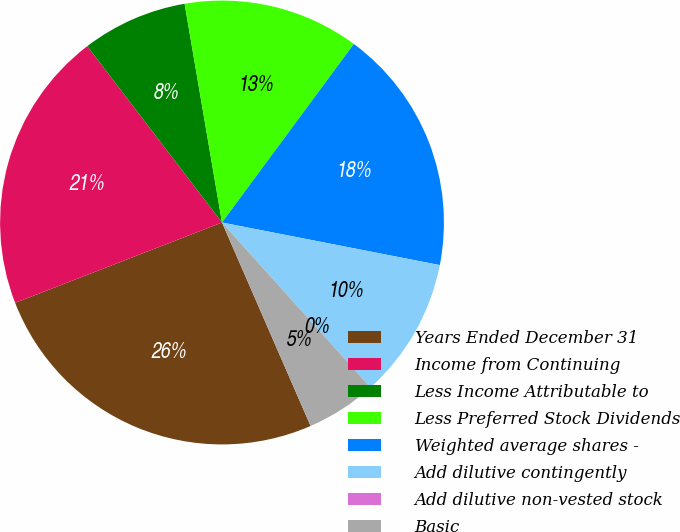<chart> <loc_0><loc_0><loc_500><loc_500><pie_chart><fcel>Years Ended December 31<fcel>Income from Continuing<fcel>Less Income Attributable to<fcel>Less Preferred Stock Dividends<fcel>Weighted average shares -<fcel>Add dilutive contingently<fcel>Add dilutive non-vested stock<fcel>Basic<nl><fcel>25.64%<fcel>20.51%<fcel>7.69%<fcel>12.82%<fcel>17.95%<fcel>10.26%<fcel>0.0%<fcel>5.13%<nl></chart> 